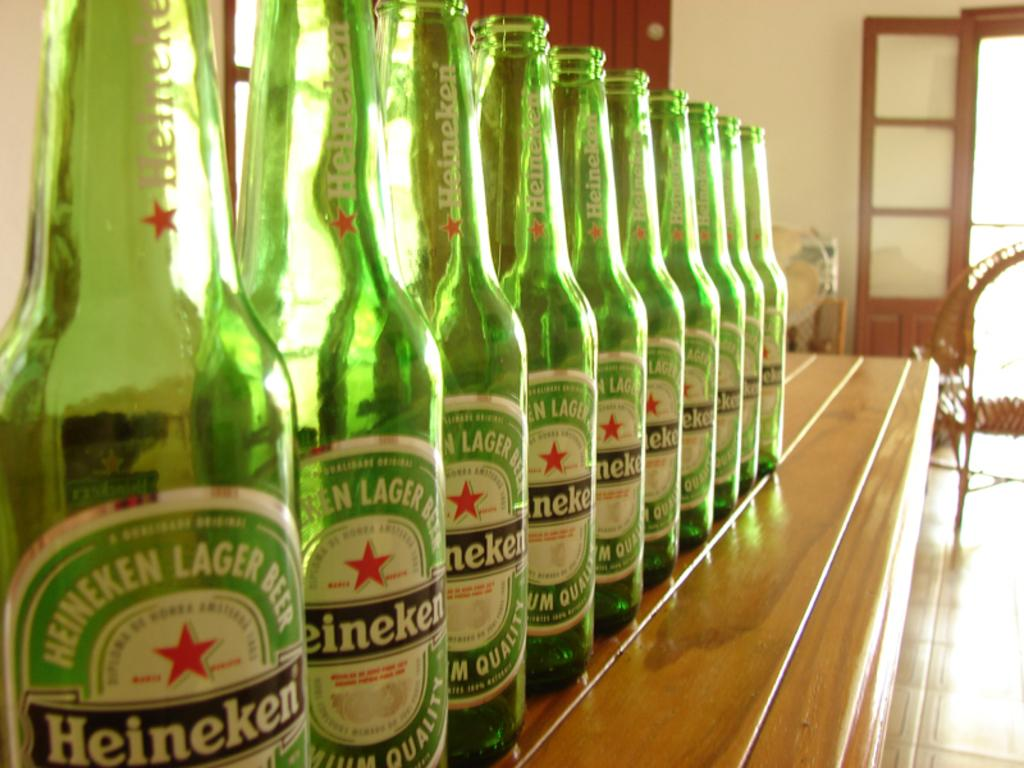<image>
Present a compact description of the photo's key features. Line up of Heineken Beer Bottles on a shelf. 